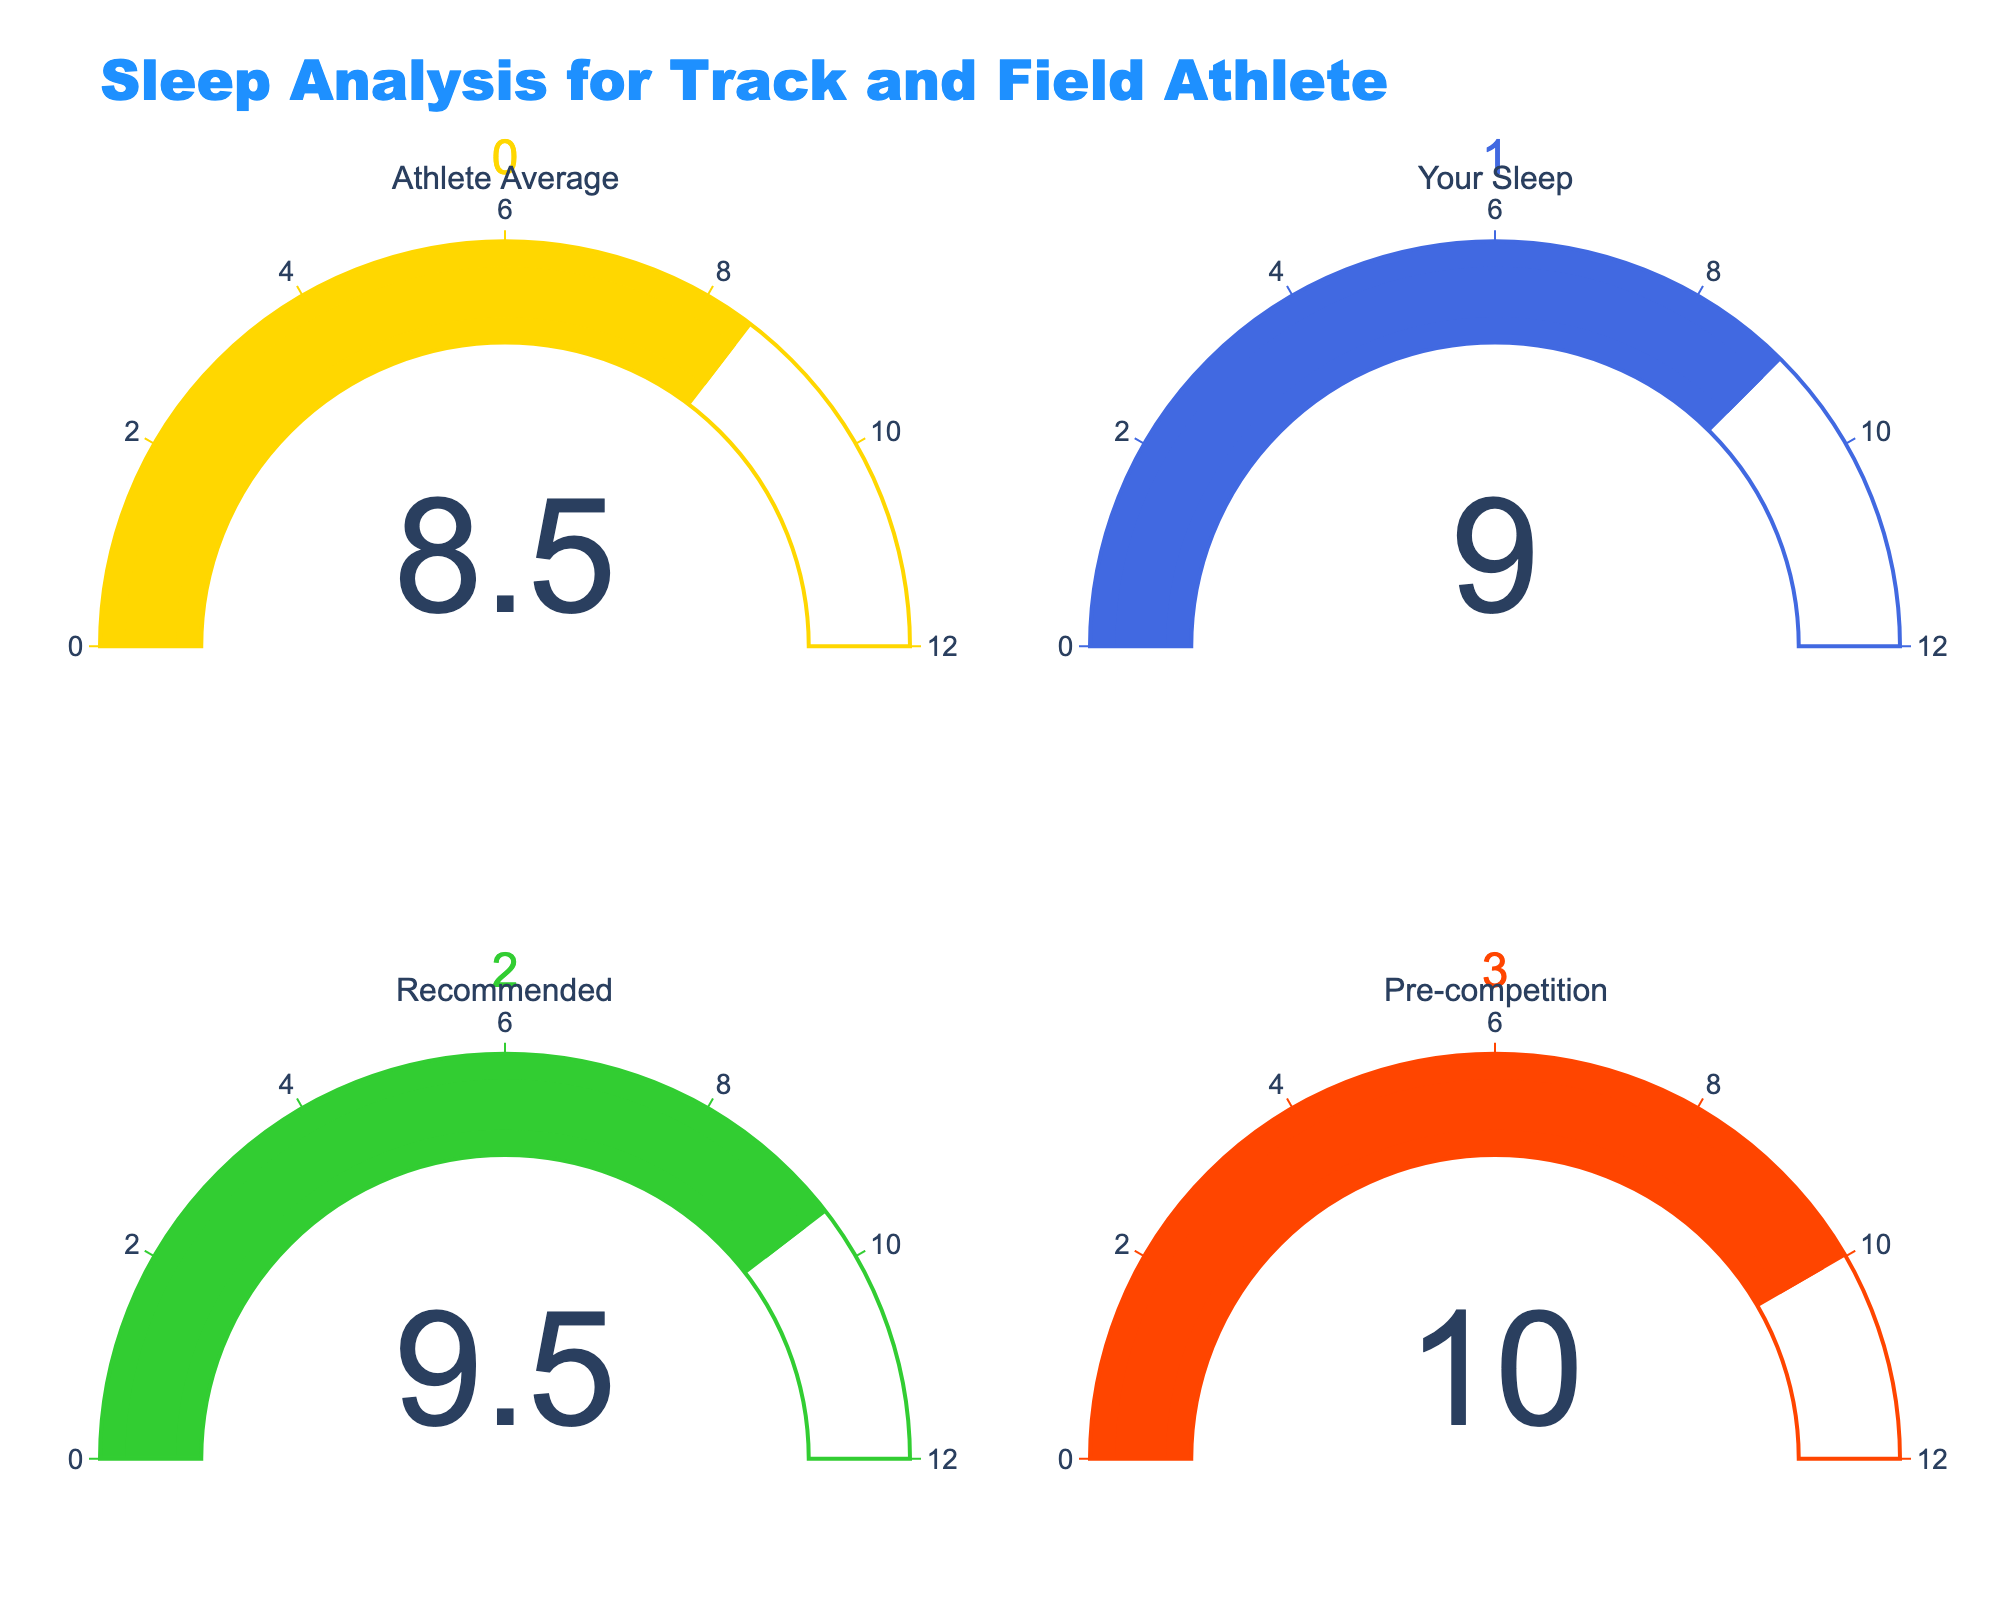What is the number of hours of sleep you had last night? The gauge labeled "Your Sleep" shows a value of 9 hours.
Answer: 9 How many more hours of sleep did you get compared to the Athlete Average? The Athlete Average is 8.5 hours, and your sleep is 9 hours. The difference is calculated as 9 - 8.5 = 0.5 hours.
Answer: 0.5 What is the title of the chart? The title is displayed at the top of the chart and reads "Sleep Analysis for Track and Field Athlete".
Answer: Sleep Analysis for Track and Field Athlete Which category has the highest recommended hours of sleep? The "Pre-competition" gauge shows the highest value at 10 hours.
Answer: Pre-competition Calculate the average number of hours from all the displayed values. The values are 8.5, 9, 9.5, and 10. The sum is 8.5 + 9 + 9.5 + 10 = 37, and the average is 37 / 4 = 9.25.
Answer: 9.25 Which category color is represented by green? According to the chart, "Recommended" is the category represented by green.
Answer: Recommended How do the hours of sleep you had last night compare to the recommended hours of sleep? Your sleep value is 9, and the recommended hours of sleep are 9.5. 9 is less than 9.5 by 0.5 hours.
Answer: Less by 0.5 hours If you aim to achieve the pre-competition sleep hours, how many more hours do you need to sleep compared to last night? Pre-competition requirement is 10 hours, and you slept 9 hours last night. The difference is 10 - 9 = 1 hour.
Answer: 1 hour What is the range of the gauge axis? The gauge axis range is displayed from 0 to 12 hours.
Answer: 0 to 12 hours What value is displayed for the Athlete Average? The gauge for Athlete Average shows a value of 8.5 hours.
Answer: 8.5 